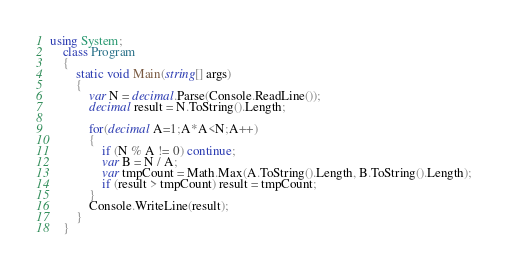<code> <loc_0><loc_0><loc_500><loc_500><_C#_>using System;
    class Program
    {
        static void Main(string[] args)
        {
            var N = decimal.Parse(Console.ReadLine());
            decimal result = N.ToString().Length;
            
            for(decimal A=1;A*A<N;A++)
            {
                if (N % A != 0) continue;
                var B = N / A;
                var tmpCount = Math.Max(A.ToString().Length, B.ToString().Length);
                if (result > tmpCount) result = tmpCount;
            }
            Console.WriteLine(result);
        }
    }</code> 